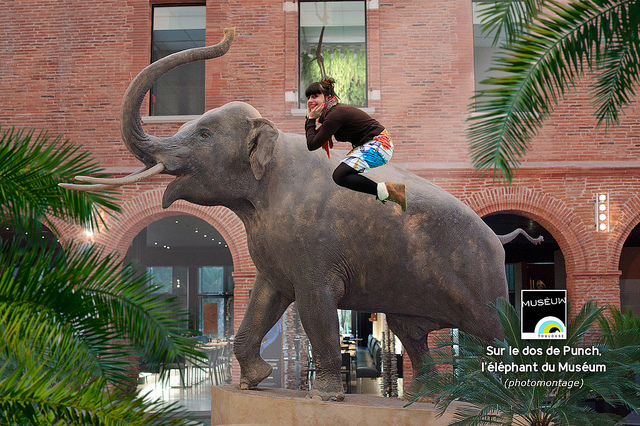Extract all visible text content from this image. MUSEUW Sur dos de Photomontage Museum du elephant i Punch, 